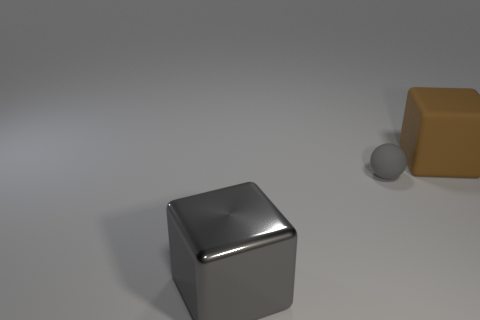Can you describe the lighting in this scene? The lighting in this scene is diffused and soft, casting gentle shadows. It seems to be coming from the top left, as indicated by the highlight on the cube and the shadows being cast to the bottom right of the objects. 